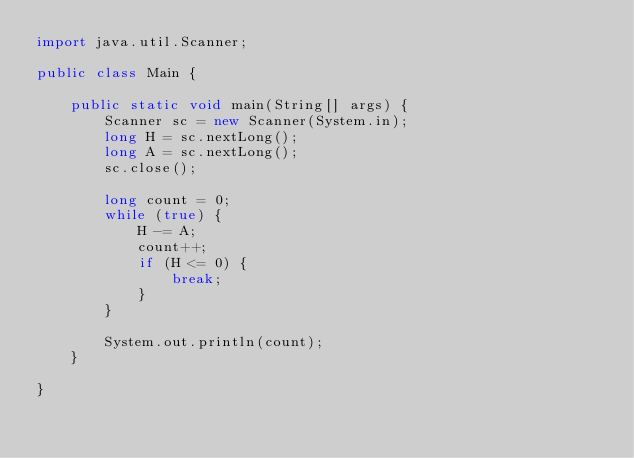Convert code to text. <code><loc_0><loc_0><loc_500><loc_500><_Java_>import java.util.Scanner;

public class Main {

    public static void main(String[] args) {
        Scanner sc = new Scanner(System.in);
        long H = sc.nextLong();
        long A = sc.nextLong();
        sc.close();

        long count = 0;
        while (true) {
            H -= A;
            count++;
            if (H <= 0) {
                break;
            }
        }

        System.out.println(count);
    }

}</code> 